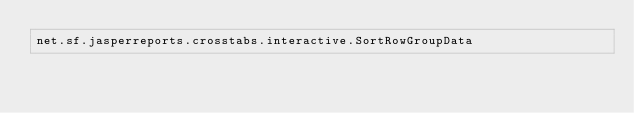Convert code to text. <code><loc_0><loc_0><loc_500><loc_500><_Rust_>net.sf.jasperreports.crosstabs.interactive.SortRowGroupData
</code> 